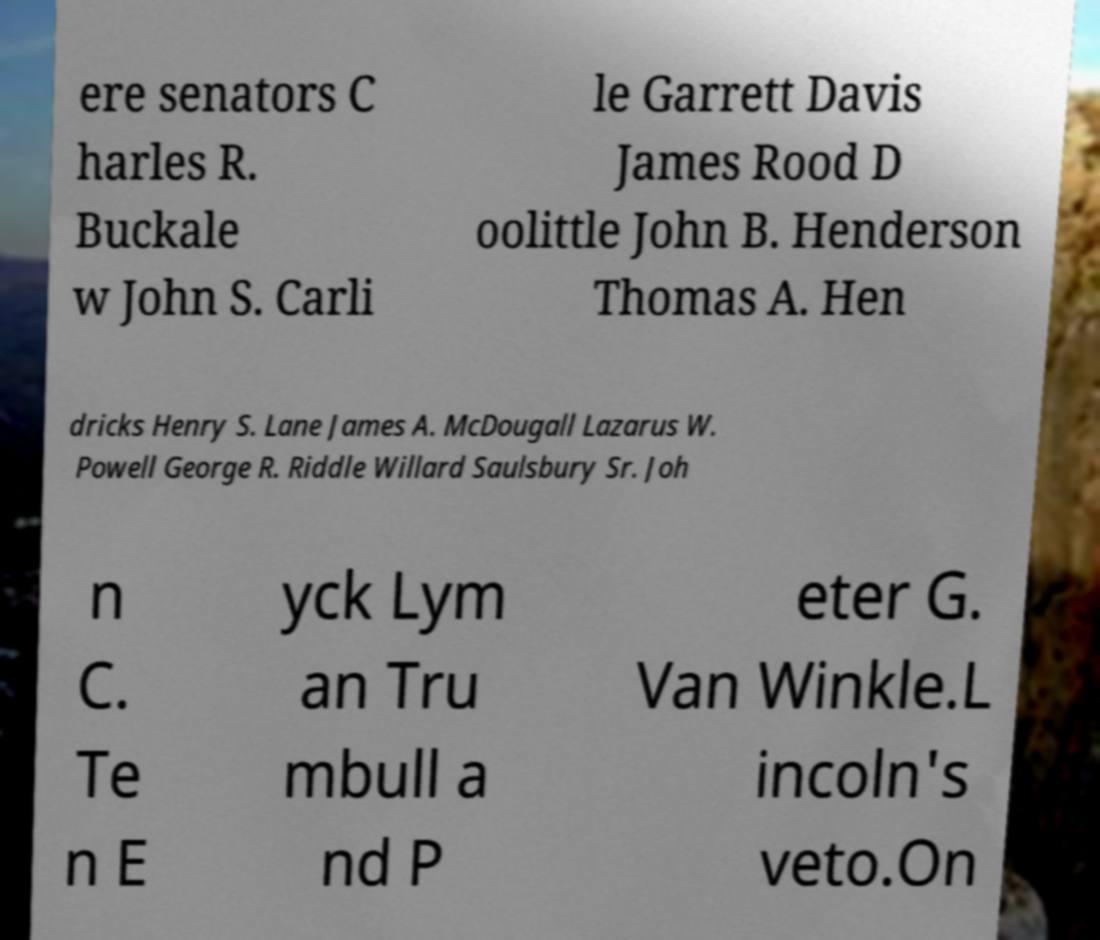Please read and relay the text visible in this image. What does it say? ere senators C harles R. Buckale w John S. Carli le Garrett Davis James Rood D oolittle John B. Henderson Thomas A. Hen dricks Henry S. Lane James A. McDougall Lazarus W. Powell George R. Riddle Willard Saulsbury Sr. Joh n C. Te n E yck Lym an Tru mbull a nd P eter G. Van Winkle.L incoln's veto.On 